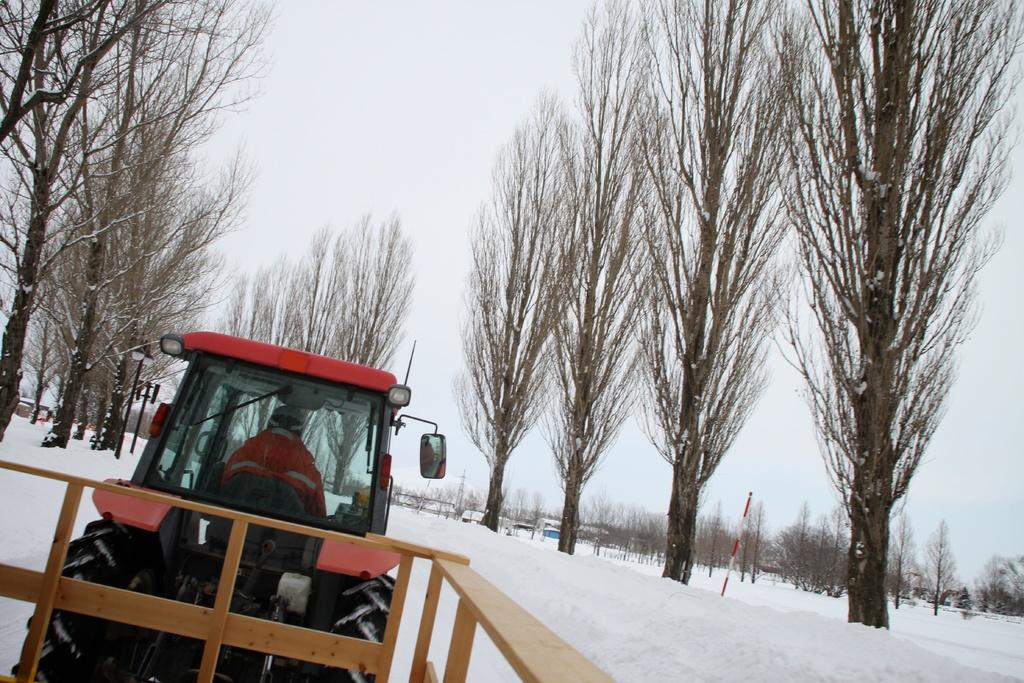What is the person in the image doing? There is a person sitting in a vehicle in the image. What type of barrier can be seen in the image? There is a wooden fence in the image. What is the weather like in the image? There is snow visible in the image, indicating a cold or wintry environment. What are the vertical structures in the image? There are poles in the image. What type of vegetation is present in the image? There are trees in the image. What can be seen in the background of the image? The sky is visible in the background of the image. What type of butter is being used to grease the sign in the image? There is no butter or sign present in the image. 